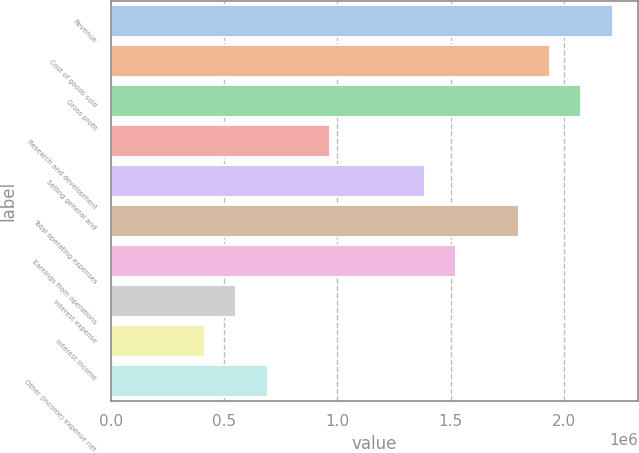Convert chart. <chart><loc_0><loc_0><loc_500><loc_500><bar_chart><fcel>Revenue<fcel>Cost of goods sold<fcel>Gross profit<fcel>Research and development<fcel>Selling general and<fcel>Total operating expenses<fcel>Earnings from operations<fcel>Interest expense<fcel>Interest income<fcel>Other (income) expense net<nl><fcel>2.21648e+06<fcel>1.93942e+06<fcel>2.07795e+06<fcel>969711<fcel>1.3853e+06<fcel>1.80089e+06<fcel>1.52383e+06<fcel>554121<fcel>415591<fcel>692651<nl></chart> 